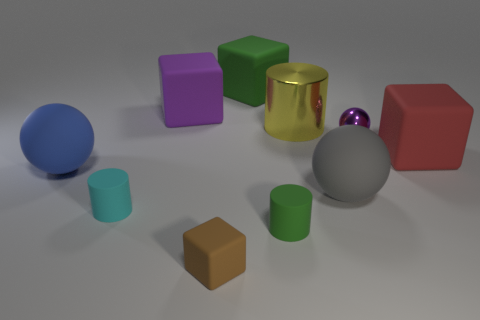What number of shiny things are brown things or big yellow cubes?
Offer a very short reply. 0. How big is the ball that is both on the right side of the small cyan cylinder and behind the large gray rubber object?
Provide a short and direct response. Small. There is a big yellow metallic thing that is behind the red matte block; is there a matte thing left of it?
Ensure brevity in your answer.  Yes. There is a purple shiny ball; what number of purple things are behind it?
Offer a very short reply. 1. What is the color of the tiny thing that is the same shape as the large purple thing?
Ensure brevity in your answer.  Brown. Is the big cube that is in front of the tiny purple metallic thing made of the same material as the gray thing on the left side of the tiny purple ball?
Offer a terse response. Yes. There is a big metallic cylinder; is its color the same as the big matte cube that is to the left of the green rubber cube?
Your response must be concise. No. The object that is both right of the tiny brown cube and behind the big yellow shiny object has what shape?
Give a very brief answer. Cube. How many large red matte blocks are there?
Your response must be concise. 1. What shape is the big matte object that is the same color as the small shiny ball?
Ensure brevity in your answer.  Cube. 